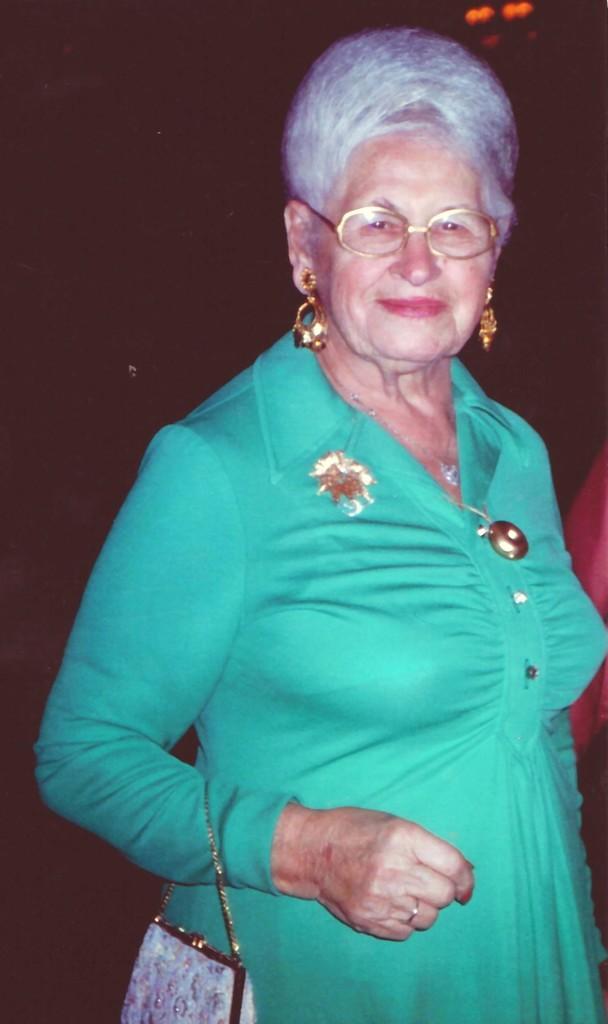Describe this image in one or two sentences. In this image I can see a woman standing. She is wearing green color dress,earrings,spectacles and she is holding hand bag which is light violet color. 